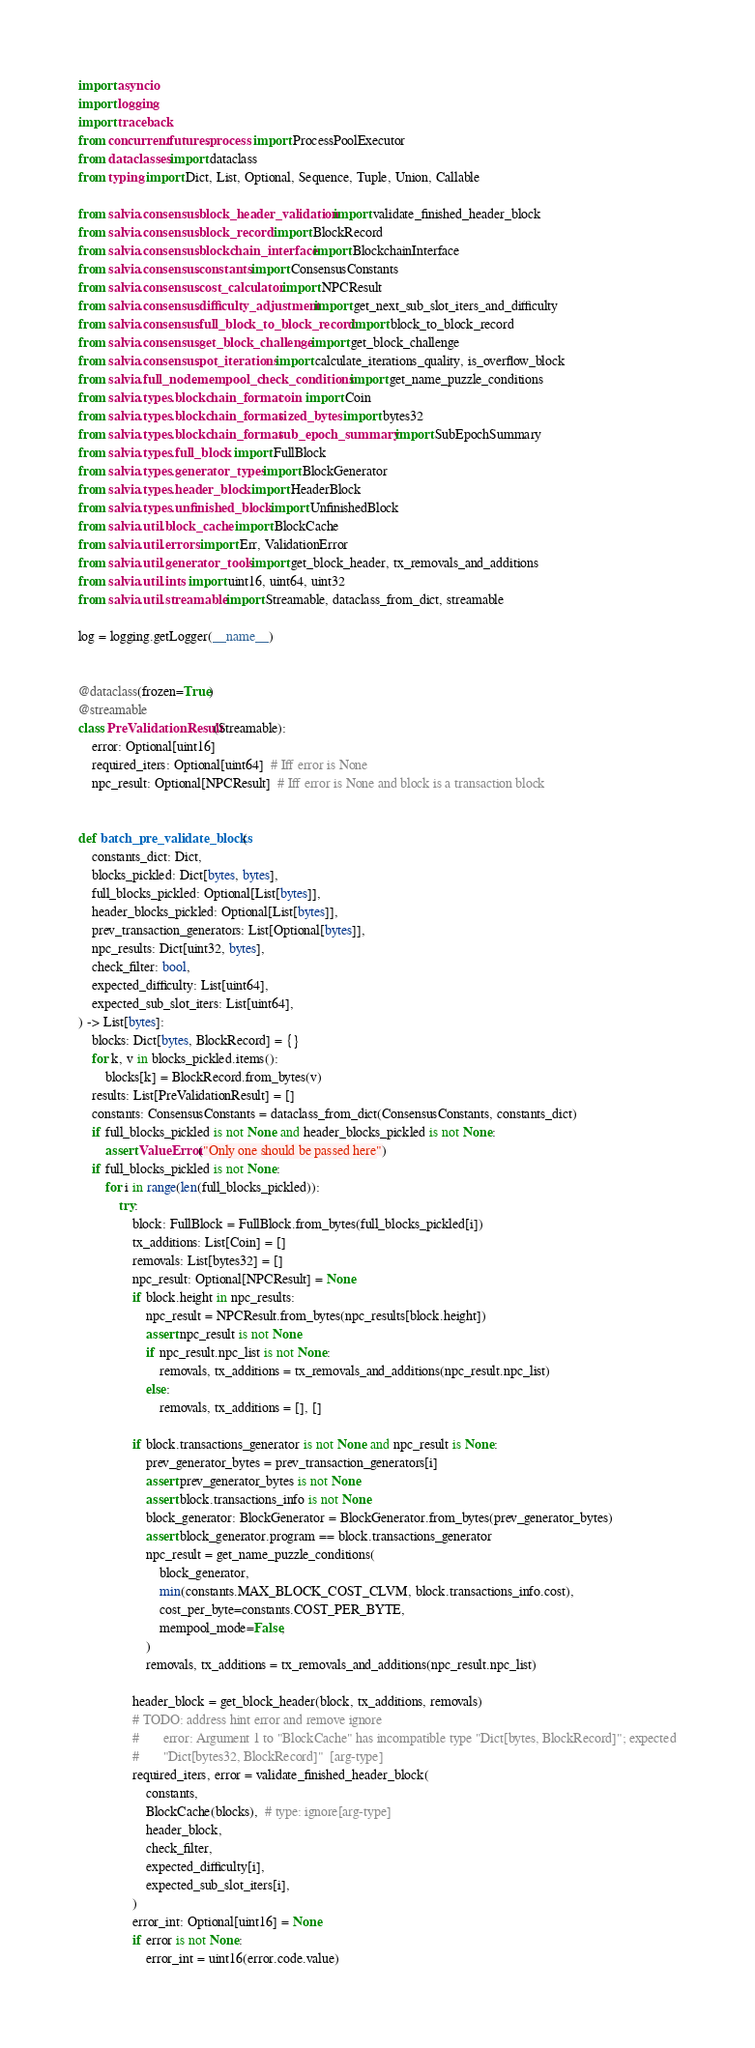<code> <loc_0><loc_0><loc_500><loc_500><_Python_>import asyncio
import logging
import traceback
from concurrent.futures.process import ProcessPoolExecutor
from dataclasses import dataclass
from typing import Dict, List, Optional, Sequence, Tuple, Union, Callable

from salvia.consensus.block_header_validation import validate_finished_header_block
from salvia.consensus.block_record import BlockRecord
from salvia.consensus.blockchain_interface import BlockchainInterface
from salvia.consensus.constants import ConsensusConstants
from salvia.consensus.cost_calculator import NPCResult
from salvia.consensus.difficulty_adjustment import get_next_sub_slot_iters_and_difficulty
from salvia.consensus.full_block_to_block_record import block_to_block_record
from salvia.consensus.get_block_challenge import get_block_challenge
from salvia.consensus.pot_iterations import calculate_iterations_quality, is_overflow_block
from salvia.full_node.mempool_check_conditions import get_name_puzzle_conditions
from salvia.types.blockchain_format.coin import Coin
from salvia.types.blockchain_format.sized_bytes import bytes32
from salvia.types.blockchain_format.sub_epoch_summary import SubEpochSummary
from salvia.types.full_block import FullBlock
from salvia.types.generator_types import BlockGenerator
from salvia.types.header_block import HeaderBlock
from salvia.types.unfinished_block import UnfinishedBlock
from salvia.util.block_cache import BlockCache
from salvia.util.errors import Err, ValidationError
from salvia.util.generator_tools import get_block_header, tx_removals_and_additions
from salvia.util.ints import uint16, uint64, uint32
from salvia.util.streamable import Streamable, dataclass_from_dict, streamable

log = logging.getLogger(__name__)


@dataclass(frozen=True)
@streamable
class PreValidationResult(Streamable):
    error: Optional[uint16]
    required_iters: Optional[uint64]  # Iff error is None
    npc_result: Optional[NPCResult]  # Iff error is None and block is a transaction block


def batch_pre_validate_blocks(
    constants_dict: Dict,
    blocks_pickled: Dict[bytes, bytes],
    full_blocks_pickled: Optional[List[bytes]],
    header_blocks_pickled: Optional[List[bytes]],
    prev_transaction_generators: List[Optional[bytes]],
    npc_results: Dict[uint32, bytes],
    check_filter: bool,
    expected_difficulty: List[uint64],
    expected_sub_slot_iters: List[uint64],
) -> List[bytes]:
    blocks: Dict[bytes, BlockRecord] = {}
    for k, v in blocks_pickled.items():
        blocks[k] = BlockRecord.from_bytes(v)
    results: List[PreValidationResult] = []
    constants: ConsensusConstants = dataclass_from_dict(ConsensusConstants, constants_dict)
    if full_blocks_pickled is not None and header_blocks_pickled is not None:
        assert ValueError("Only one should be passed here")
    if full_blocks_pickled is not None:
        for i in range(len(full_blocks_pickled)):
            try:
                block: FullBlock = FullBlock.from_bytes(full_blocks_pickled[i])
                tx_additions: List[Coin] = []
                removals: List[bytes32] = []
                npc_result: Optional[NPCResult] = None
                if block.height in npc_results:
                    npc_result = NPCResult.from_bytes(npc_results[block.height])
                    assert npc_result is not None
                    if npc_result.npc_list is not None:
                        removals, tx_additions = tx_removals_and_additions(npc_result.npc_list)
                    else:
                        removals, tx_additions = [], []

                if block.transactions_generator is not None and npc_result is None:
                    prev_generator_bytes = prev_transaction_generators[i]
                    assert prev_generator_bytes is not None
                    assert block.transactions_info is not None
                    block_generator: BlockGenerator = BlockGenerator.from_bytes(prev_generator_bytes)
                    assert block_generator.program == block.transactions_generator
                    npc_result = get_name_puzzle_conditions(
                        block_generator,
                        min(constants.MAX_BLOCK_COST_CLVM, block.transactions_info.cost),
                        cost_per_byte=constants.COST_PER_BYTE,
                        mempool_mode=False,
                    )
                    removals, tx_additions = tx_removals_and_additions(npc_result.npc_list)

                header_block = get_block_header(block, tx_additions, removals)
                # TODO: address hint error and remove ignore
                #       error: Argument 1 to "BlockCache" has incompatible type "Dict[bytes, BlockRecord]"; expected
                #       "Dict[bytes32, BlockRecord]"  [arg-type]
                required_iters, error = validate_finished_header_block(
                    constants,
                    BlockCache(blocks),  # type: ignore[arg-type]
                    header_block,
                    check_filter,
                    expected_difficulty[i],
                    expected_sub_slot_iters[i],
                )
                error_int: Optional[uint16] = None
                if error is not None:
                    error_int = uint16(error.code.value)
</code> 